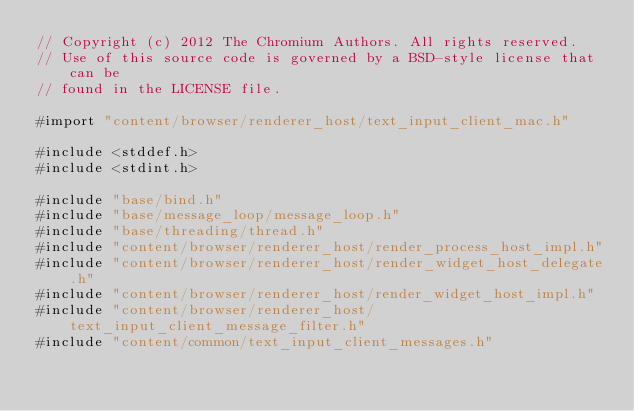Convert code to text. <code><loc_0><loc_0><loc_500><loc_500><_ObjectiveC_>// Copyright (c) 2012 The Chromium Authors. All rights reserved.
// Use of this source code is governed by a BSD-style license that can be
// found in the LICENSE file.

#import "content/browser/renderer_host/text_input_client_mac.h"

#include <stddef.h>
#include <stdint.h>

#include "base/bind.h"
#include "base/message_loop/message_loop.h"
#include "base/threading/thread.h"
#include "content/browser/renderer_host/render_process_host_impl.h"
#include "content/browser/renderer_host/render_widget_host_delegate.h"
#include "content/browser/renderer_host/render_widget_host_impl.h"
#include "content/browser/renderer_host/text_input_client_message_filter.h"
#include "content/common/text_input_client_messages.h"</code> 